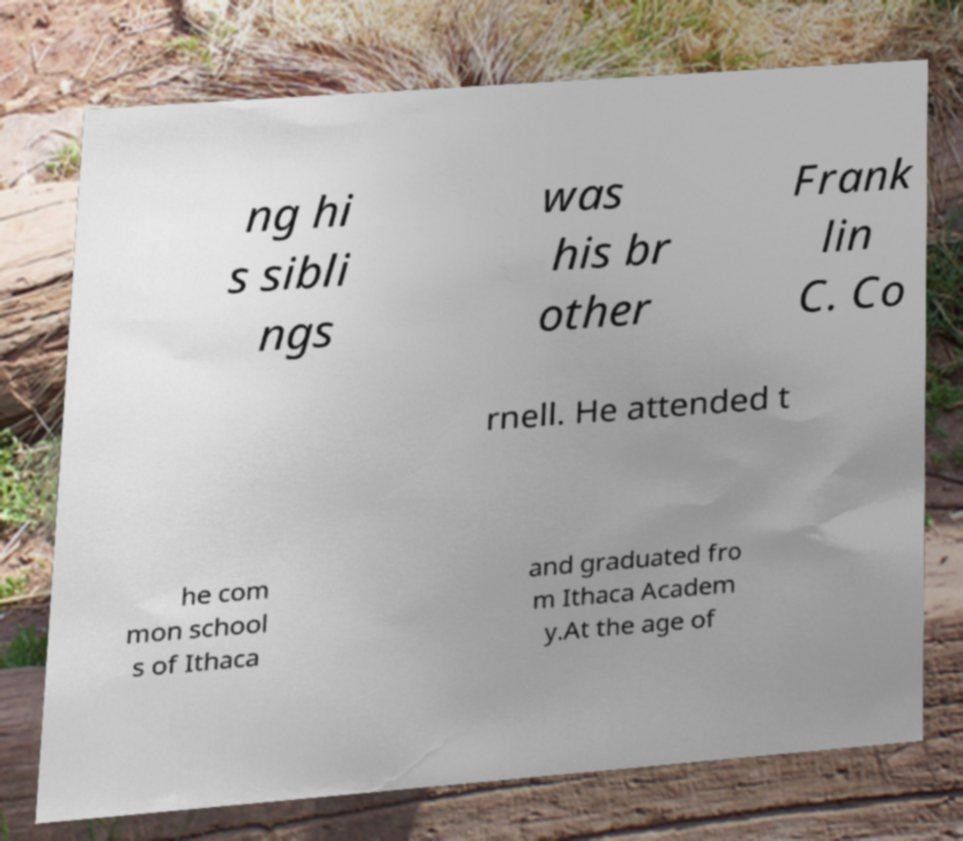I need the written content from this picture converted into text. Can you do that? ng hi s sibli ngs was his br other Frank lin C. Co rnell. He attended t he com mon school s of Ithaca and graduated fro m Ithaca Academ y.At the age of 